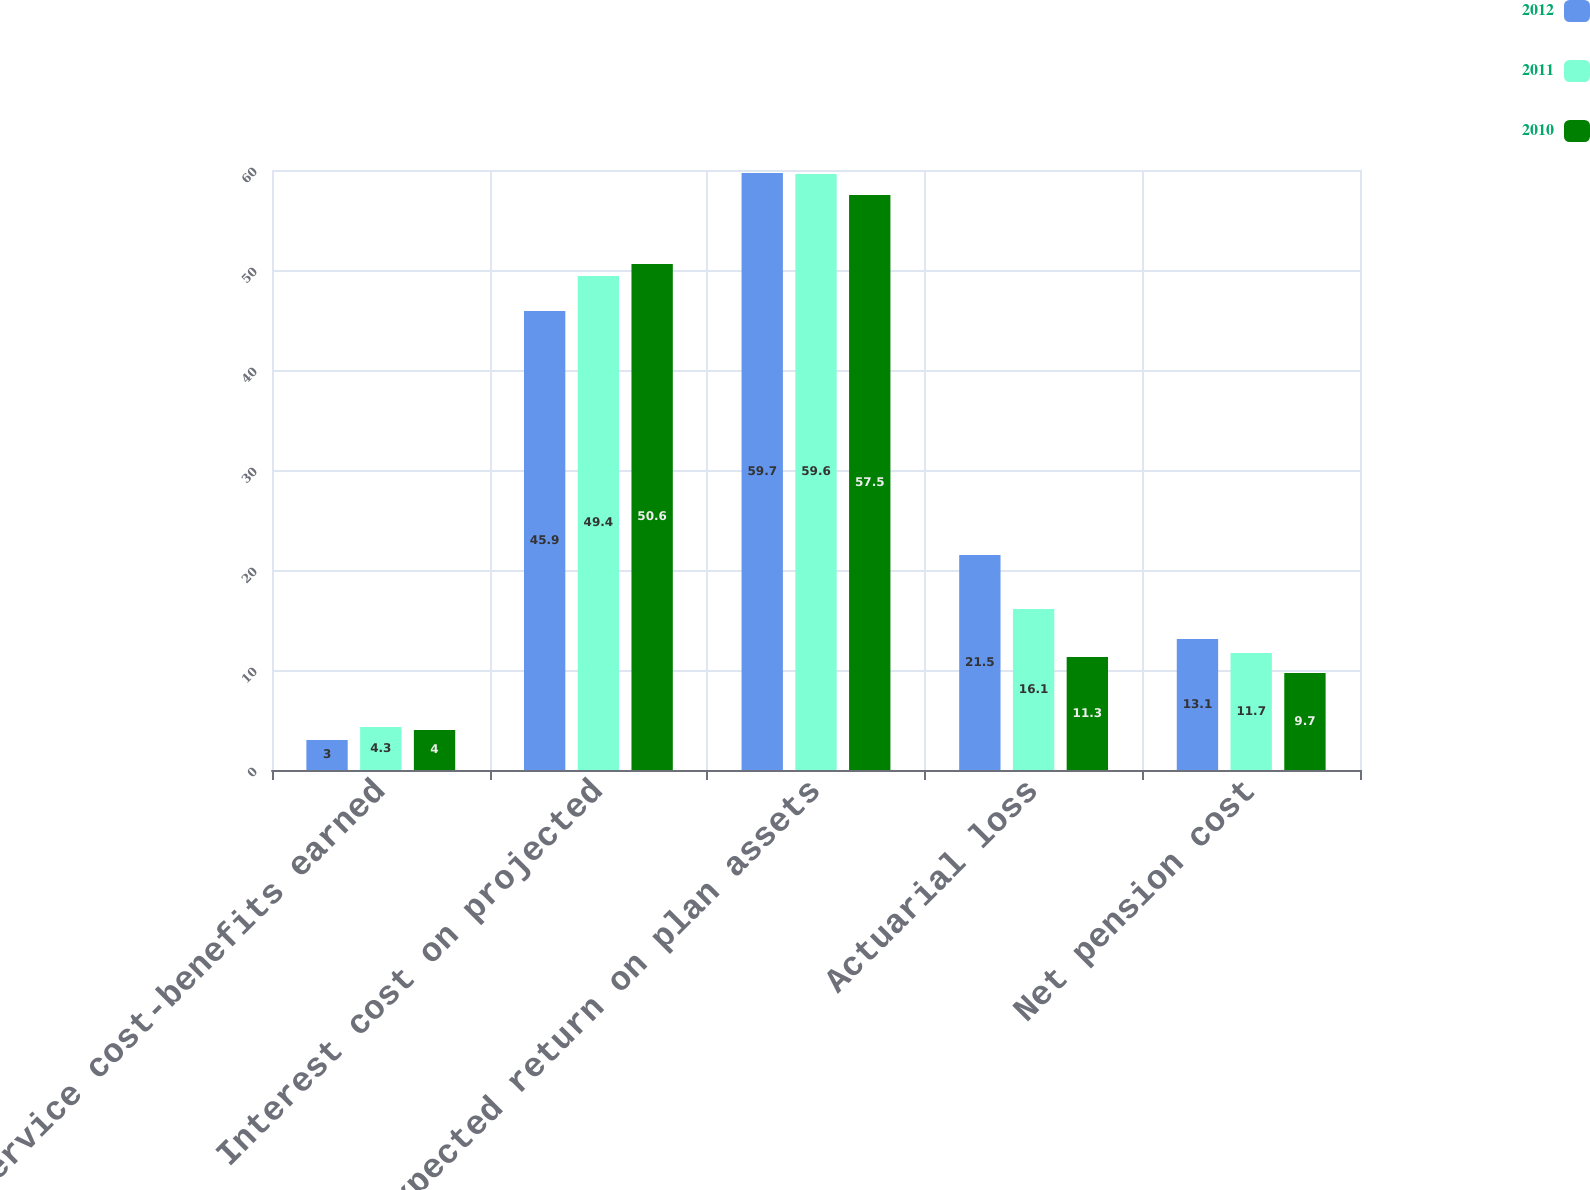Convert chart. <chart><loc_0><loc_0><loc_500><loc_500><stacked_bar_chart><ecel><fcel>Service cost-benefits earned<fcel>Interest cost on projected<fcel>Expected return on plan assets<fcel>Actuarial loss<fcel>Net pension cost<nl><fcel>2012<fcel>3<fcel>45.9<fcel>59.7<fcel>21.5<fcel>13.1<nl><fcel>2011<fcel>4.3<fcel>49.4<fcel>59.6<fcel>16.1<fcel>11.7<nl><fcel>2010<fcel>4<fcel>50.6<fcel>57.5<fcel>11.3<fcel>9.7<nl></chart> 